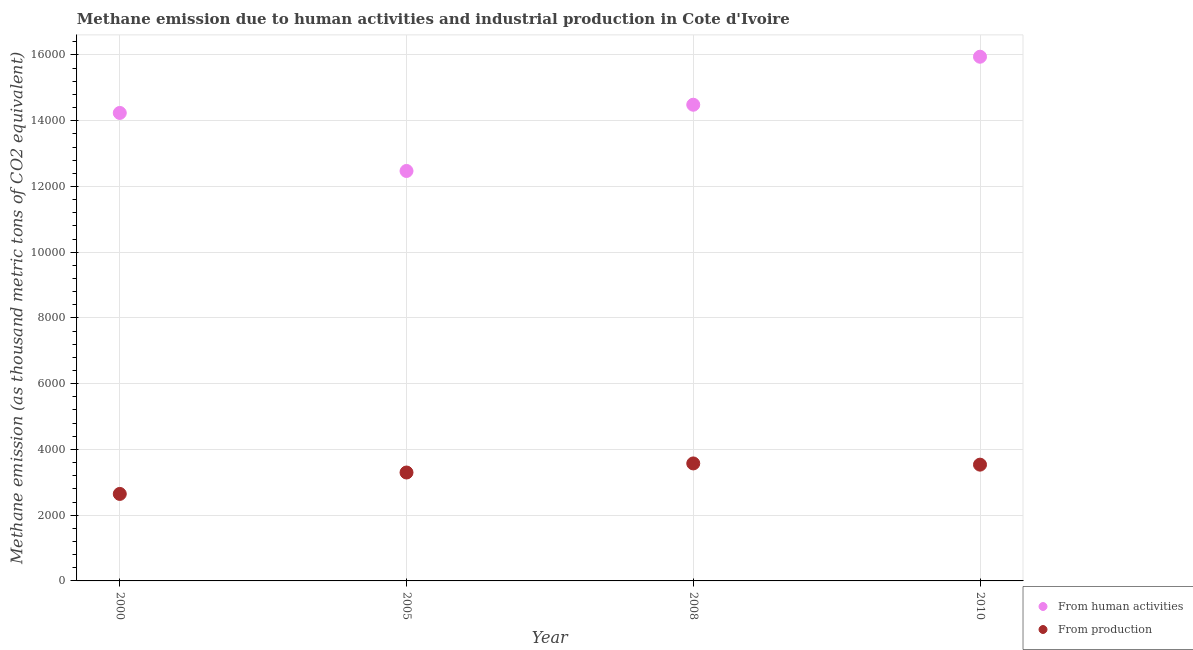How many different coloured dotlines are there?
Make the answer very short. 2. What is the amount of emissions from human activities in 2000?
Keep it short and to the point. 1.42e+04. Across all years, what is the maximum amount of emissions from human activities?
Offer a very short reply. 1.59e+04. Across all years, what is the minimum amount of emissions generated from industries?
Ensure brevity in your answer.  2646.7. In which year was the amount of emissions generated from industries maximum?
Give a very brief answer. 2008. What is the total amount of emissions from human activities in the graph?
Make the answer very short. 5.71e+04. What is the difference between the amount of emissions from human activities in 2000 and that in 2005?
Your answer should be compact. 1765.3. What is the difference between the amount of emissions generated from industries in 2010 and the amount of emissions from human activities in 2000?
Ensure brevity in your answer.  -1.07e+04. What is the average amount of emissions from human activities per year?
Your response must be concise. 1.43e+04. In the year 2010, what is the difference between the amount of emissions from human activities and amount of emissions generated from industries?
Your response must be concise. 1.24e+04. In how many years, is the amount of emissions generated from industries greater than 14800 thousand metric tons?
Offer a terse response. 0. What is the ratio of the amount of emissions from human activities in 2000 to that in 2005?
Offer a terse response. 1.14. Is the amount of emissions from human activities in 2000 less than that in 2008?
Ensure brevity in your answer.  Yes. What is the difference between the highest and the second highest amount of emissions generated from industries?
Keep it short and to the point. 37.1. What is the difference between the highest and the lowest amount of emissions from human activities?
Offer a terse response. 3475.3. In how many years, is the amount of emissions from human activities greater than the average amount of emissions from human activities taken over all years?
Provide a short and direct response. 2. Is the sum of the amount of emissions generated from industries in 2008 and 2010 greater than the maximum amount of emissions from human activities across all years?
Offer a terse response. No. Does the amount of emissions from human activities monotonically increase over the years?
Provide a short and direct response. No. Is the amount of emissions generated from industries strictly less than the amount of emissions from human activities over the years?
Your response must be concise. Yes. What is the difference between two consecutive major ticks on the Y-axis?
Provide a short and direct response. 2000. Are the values on the major ticks of Y-axis written in scientific E-notation?
Provide a short and direct response. No. How many legend labels are there?
Your response must be concise. 2. What is the title of the graph?
Ensure brevity in your answer.  Methane emission due to human activities and industrial production in Cote d'Ivoire. Does "All education staff compensation" appear as one of the legend labels in the graph?
Provide a succinct answer. No. What is the label or title of the Y-axis?
Make the answer very short. Methane emission (as thousand metric tons of CO2 equivalent). What is the Methane emission (as thousand metric tons of CO2 equivalent) of From human activities in 2000?
Your response must be concise. 1.42e+04. What is the Methane emission (as thousand metric tons of CO2 equivalent) in From production in 2000?
Make the answer very short. 2646.7. What is the Methane emission (as thousand metric tons of CO2 equivalent) in From human activities in 2005?
Keep it short and to the point. 1.25e+04. What is the Methane emission (as thousand metric tons of CO2 equivalent) of From production in 2005?
Provide a short and direct response. 3298.2. What is the Methane emission (as thousand metric tons of CO2 equivalent) in From human activities in 2008?
Provide a succinct answer. 1.45e+04. What is the Methane emission (as thousand metric tons of CO2 equivalent) in From production in 2008?
Keep it short and to the point. 3574.4. What is the Methane emission (as thousand metric tons of CO2 equivalent) of From human activities in 2010?
Keep it short and to the point. 1.59e+04. What is the Methane emission (as thousand metric tons of CO2 equivalent) of From production in 2010?
Your answer should be very brief. 3537.3. Across all years, what is the maximum Methane emission (as thousand metric tons of CO2 equivalent) of From human activities?
Provide a succinct answer. 1.59e+04. Across all years, what is the maximum Methane emission (as thousand metric tons of CO2 equivalent) in From production?
Make the answer very short. 3574.4. Across all years, what is the minimum Methane emission (as thousand metric tons of CO2 equivalent) in From human activities?
Provide a short and direct response. 1.25e+04. Across all years, what is the minimum Methane emission (as thousand metric tons of CO2 equivalent) of From production?
Offer a very short reply. 2646.7. What is the total Methane emission (as thousand metric tons of CO2 equivalent) of From human activities in the graph?
Your response must be concise. 5.71e+04. What is the total Methane emission (as thousand metric tons of CO2 equivalent) in From production in the graph?
Your answer should be very brief. 1.31e+04. What is the difference between the Methane emission (as thousand metric tons of CO2 equivalent) in From human activities in 2000 and that in 2005?
Ensure brevity in your answer.  1765.3. What is the difference between the Methane emission (as thousand metric tons of CO2 equivalent) of From production in 2000 and that in 2005?
Your answer should be very brief. -651.5. What is the difference between the Methane emission (as thousand metric tons of CO2 equivalent) in From human activities in 2000 and that in 2008?
Offer a very short reply. -249.8. What is the difference between the Methane emission (as thousand metric tons of CO2 equivalent) in From production in 2000 and that in 2008?
Ensure brevity in your answer.  -927.7. What is the difference between the Methane emission (as thousand metric tons of CO2 equivalent) of From human activities in 2000 and that in 2010?
Offer a terse response. -1710. What is the difference between the Methane emission (as thousand metric tons of CO2 equivalent) in From production in 2000 and that in 2010?
Provide a succinct answer. -890.6. What is the difference between the Methane emission (as thousand metric tons of CO2 equivalent) in From human activities in 2005 and that in 2008?
Make the answer very short. -2015.1. What is the difference between the Methane emission (as thousand metric tons of CO2 equivalent) in From production in 2005 and that in 2008?
Your answer should be very brief. -276.2. What is the difference between the Methane emission (as thousand metric tons of CO2 equivalent) in From human activities in 2005 and that in 2010?
Ensure brevity in your answer.  -3475.3. What is the difference between the Methane emission (as thousand metric tons of CO2 equivalent) of From production in 2005 and that in 2010?
Keep it short and to the point. -239.1. What is the difference between the Methane emission (as thousand metric tons of CO2 equivalent) of From human activities in 2008 and that in 2010?
Provide a short and direct response. -1460.2. What is the difference between the Methane emission (as thousand metric tons of CO2 equivalent) in From production in 2008 and that in 2010?
Your response must be concise. 37.1. What is the difference between the Methane emission (as thousand metric tons of CO2 equivalent) of From human activities in 2000 and the Methane emission (as thousand metric tons of CO2 equivalent) of From production in 2005?
Your answer should be compact. 1.09e+04. What is the difference between the Methane emission (as thousand metric tons of CO2 equivalent) of From human activities in 2000 and the Methane emission (as thousand metric tons of CO2 equivalent) of From production in 2008?
Offer a very short reply. 1.07e+04. What is the difference between the Methane emission (as thousand metric tons of CO2 equivalent) in From human activities in 2000 and the Methane emission (as thousand metric tons of CO2 equivalent) in From production in 2010?
Your response must be concise. 1.07e+04. What is the difference between the Methane emission (as thousand metric tons of CO2 equivalent) in From human activities in 2005 and the Methane emission (as thousand metric tons of CO2 equivalent) in From production in 2008?
Your answer should be compact. 8897.1. What is the difference between the Methane emission (as thousand metric tons of CO2 equivalent) of From human activities in 2005 and the Methane emission (as thousand metric tons of CO2 equivalent) of From production in 2010?
Offer a very short reply. 8934.2. What is the difference between the Methane emission (as thousand metric tons of CO2 equivalent) in From human activities in 2008 and the Methane emission (as thousand metric tons of CO2 equivalent) in From production in 2010?
Make the answer very short. 1.09e+04. What is the average Methane emission (as thousand metric tons of CO2 equivalent) of From human activities per year?
Ensure brevity in your answer.  1.43e+04. What is the average Methane emission (as thousand metric tons of CO2 equivalent) of From production per year?
Offer a terse response. 3264.15. In the year 2000, what is the difference between the Methane emission (as thousand metric tons of CO2 equivalent) in From human activities and Methane emission (as thousand metric tons of CO2 equivalent) in From production?
Provide a short and direct response. 1.16e+04. In the year 2005, what is the difference between the Methane emission (as thousand metric tons of CO2 equivalent) of From human activities and Methane emission (as thousand metric tons of CO2 equivalent) of From production?
Ensure brevity in your answer.  9173.3. In the year 2008, what is the difference between the Methane emission (as thousand metric tons of CO2 equivalent) in From human activities and Methane emission (as thousand metric tons of CO2 equivalent) in From production?
Give a very brief answer. 1.09e+04. In the year 2010, what is the difference between the Methane emission (as thousand metric tons of CO2 equivalent) in From human activities and Methane emission (as thousand metric tons of CO2 equivalent) in From production?
Your response must be concise. 1.24e+04. What is the ratio of the Methane emission (as thousand metric tons of CO2 equivalent) of From human activities in 2000 to that in 2005?
Provide a short and direct response. 1.14. What is the ratio of the Methane emission (as thousand metric tons of CO2 equivalent) of From production in 2000 to that in 2005?
Ensure brevity in your answer.  0.8. What is the ratio of the Methane emission (as thousand metric tons of CO2 equivalent) of From human activities in 2000 to that in 2008?
Keep it short and to the point. 0.98. What is the ratio of the Methane emission (as thousand metric tons of CO2 equivalent) in From production in 2000 to that in 2008?
Provide a short and direct response. 0.74. What is the ratio of the Methane emission (as thousand metric tons of CO2 equivalent) of From human activities in 2000 to that in 2010?
Your answer should be very brief. 0.89. What is the ratio of the Methane emission (as thousand metric tons of CO2 equivalent) of From production in 2000 to that in 2010?
Your answer should be very brief. 0.75. What is the ratio of the Methane emission (as thousand metric tons of CO2 equivalent) of From human activities in 2005 to that in 2008?
Your answer should be very brief. 0.86. What is the ratio of the Methane emission (as thousand metric tons of CO2 equivalent) in From production in 2005 to that in 2008?
Make the answer very short. 0.92. What is the ratio of the Methane emission (as thousand metric tons of CO2 equivalent) in From human activities in 2005 to that in 2010?
Give a very brief answer. 0.78. What is the ratio of the Methane emission (as thousand metric tons of CO2 equivalent) in From production in 2005 to that in 2010?
Your answer should be compact. 0.93. What is the ratio of the Methane emission (as thousand metric tons of CO2 equivalent) of From human activities in 2008 to that in 2010?
Make the answer very short. 0.91. What is the ratio of the Methane emission (as thousand metric tons of CO2 equivalent) of From production in 2008 to that in 2010?
Make the answer very short. 1.01. What is the difference between the highest and the second highest Methane emission (as thousand metric tons of CO2 equivalent) of From human activities?
Keep it short and to the point. 1460.2. What is the difference between the highest and the second highest Methane emission (as thousand metric tons of CO2 equivalent) in From production?
Make the answer very short. 37.1. What is the difference between the highest and the lowest Methane emission (as thousand metric tons of CO2 equivalent) in From human activities?
Make the answer very short. 3475.3. What is the difference between the highest and the lowest Methane emission (as thousand metric tons of CO2 equivalent) of From production?
Keep it short and to the point. 927.7. 